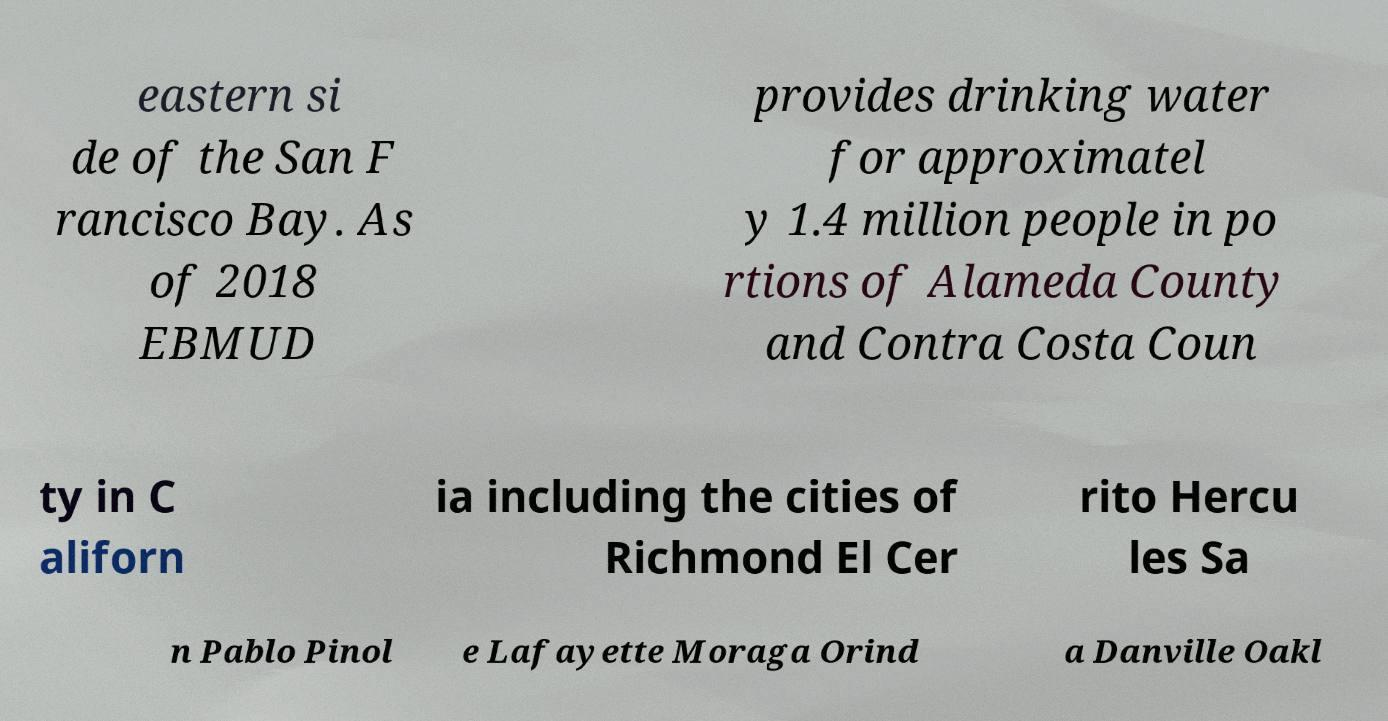Could you extract and type out the text from this image? eastern si de of the San F rancisco Bay. As of 2018 EBMUD provides drinking water for approximatel y 1.4 million people in po rtions of Alameda County and Contra Costa Coun ty in C aliforn ia including the cities of Richmond El Cer rito Hercu les Sa n Pablo Pinol e Lafayette Moraga Orind a Danville Oakl 